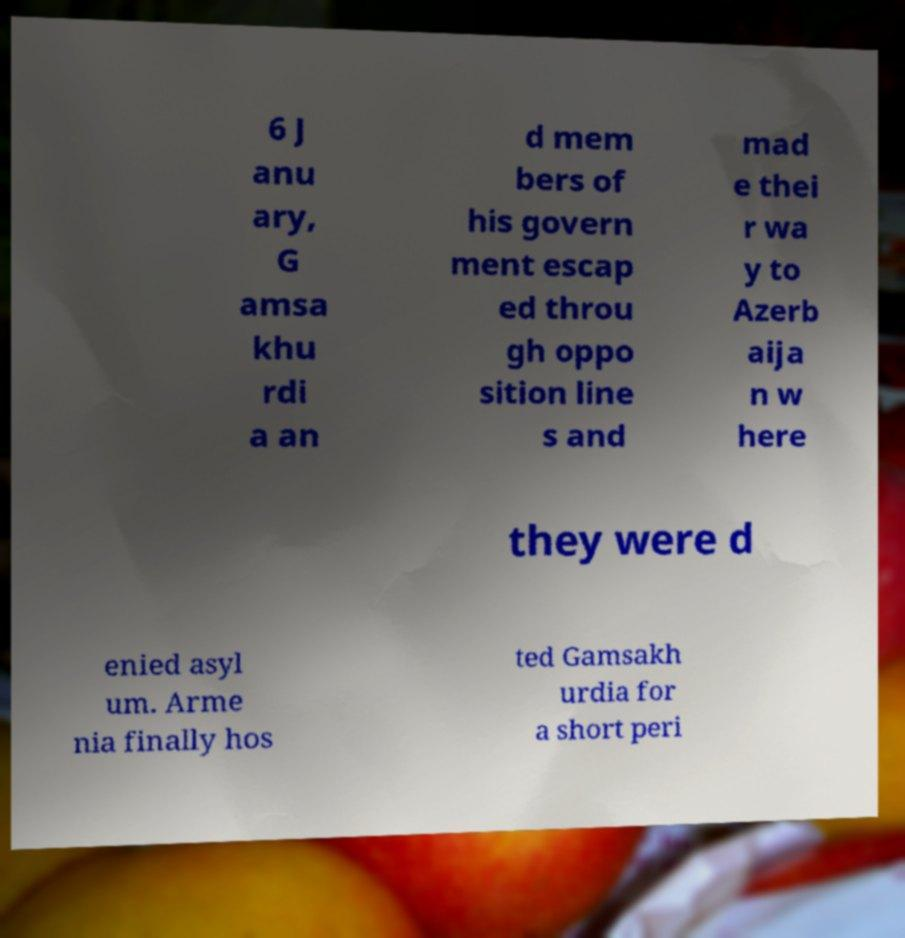What messages or text are displayed in this image? I need them in a readable, typed format. 6 J anu ary, G amsa khu rdi a an d mem bers of his govern ment escap ed throu gh oppo sition line s and mad e thei r wa y to Azerb aija n w here they were d enied asyl um. Arme nia finally hos ted Gamsakh urdia for a short peri 